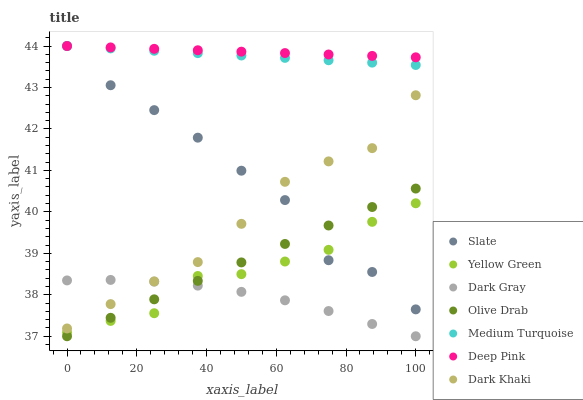Does Dark Gray have the minimum area under the curve?
Answer yes or no. Yes. Does Deep Pink have the maximum area under the curve?
Answer yes or no. Yes. Does Yellow Green have the minimum area under the curve?
Answer yes or no. No. Does Yellow Green have the maximum area under the curve?
Answer yes or no. No. Is Deep Pink the smoothest?
Answer yes or no. Yes. Is Slate the roughest?
Answer yes or no. Yes. Is Yellow Green the smoothest?
Answer yes or no. No. Is Yellow Green the roughest?
Answer yes or no. No. Does Dark Gray have the lowest value?
Answer yes or no. Yes. Does Yellow Green have the lowest value?
Answer yes or no. No. Does Medium Turquoise have the highest value?
Answer yes or no. Yes. Does Yellow Green have the highest value?
Answer yes or no. No. Is Olive Drab less than Medium Turquoise?
Answer yes or no. Yes. Is Medium Turquoise greater than Olive Drab?
Answer yes or no. Yes. Does Medium Turquoise intersect Deep Pink?
Answer yes or no. Yes. Is Medium Turquoise less than Deep Pink?
Answer yes or no. No. Is Medium Turquoise greater than Deep Pink?
Answer yes or no. No. Does Olive Drab intersect Medium Turquoise?
Answer yes or no. No. 